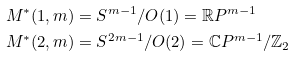<formula> <loc_0><loc_0><loc_500><loc_500>M ^ { \ast } ( 1 , m ) & = S ^ { m - 1 } / O ( 1 ) = \mathbb { R } P ^ { m - 1 } \ \\ M ^ { \ast } ( 2 , m ) & = S ^ { 2 m - 1 } / O ( 2 ) = \mathbb { C } P ^ { m - 1 } / \mathbb { Z } _ { 2 }</formula> 